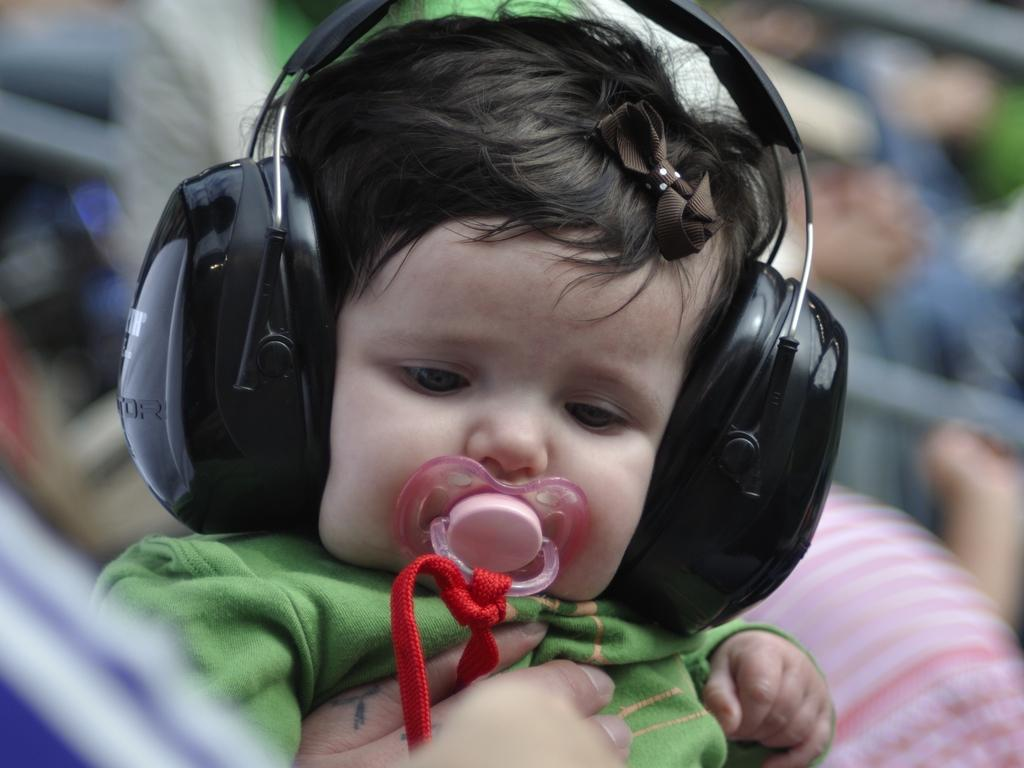What is the main subject of the picture? The main subject of the picture is a baby. What is the baby wearing in the image? The baby is wearing a green shirt and earphones. Can you describe the background of the image? The backdrop of the image is blurred. What type of disease can be seen affecting the baby in the image? There is no indication of any disease affecting the baby in the image. 